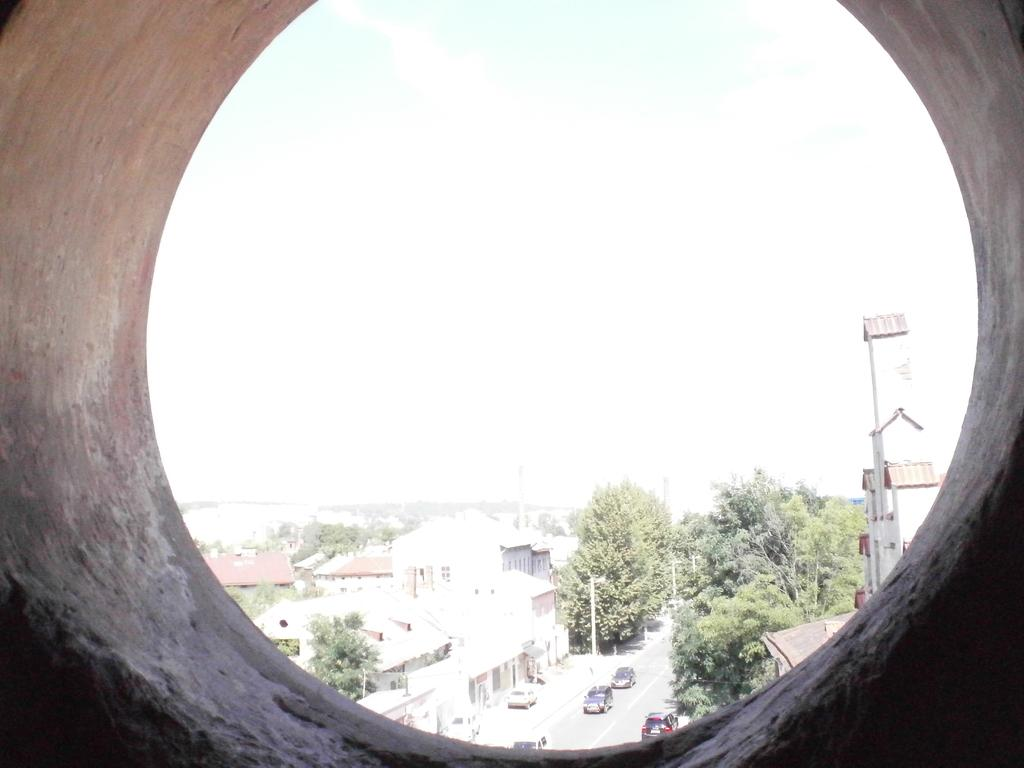What is located in the foreground of the image? There is a cement pipe in the foreground of the image. What can be seen in the background of the image? There are houses, trees, roads, poles, and vehicles in the background of the image. How many types of structures are visible in the background? There are at least two types of structures visible in the background: houses and poles. What type of vegetation is present in the background? Trees are present in the background of the image. What type of toys can be seen scattered around the cement pipe in the image? There are no toys present in the image; it only features a cement pipe in the foreground and various elements in the background. 